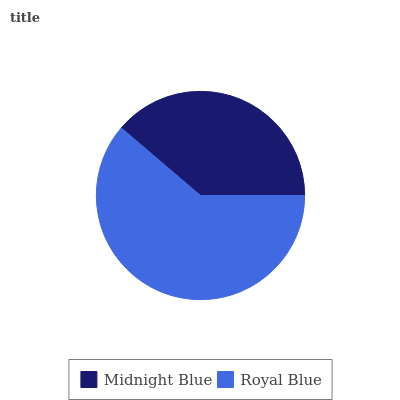Is Midnight Blue the minimum?
Answer yes or no. Yes. Is Royal Blue the maximum?
Answer yes or no. Yes. Is Royal Blue the minimum?
Answer yes or no. No. Is Royal Blue greater than Midnight Blue?
Answer yes or no. Yes. Is Midnight Blue less than Royal Blue?
Answer yes or no. Yes. Is Midnight Blue greater than Royal Blue?
Answer yes or no. No. Is Royal Blue less than Midnight Blue?
Answer yes or no. No. Is Royal Blue the high median?
Answer yes or no. Yes. Is Midnight Blue the low median?
Answer yes or no. Yes. Is Midnight Blue the high median?
Answer yes or no. No. Is Royal Blue the low median?
Answer yes or no. No. 